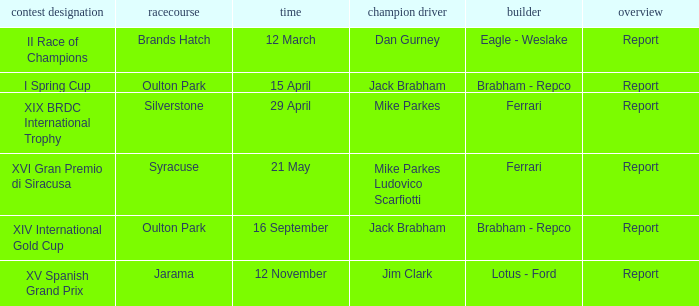What date was the xiv international gold cup? 16 September. 